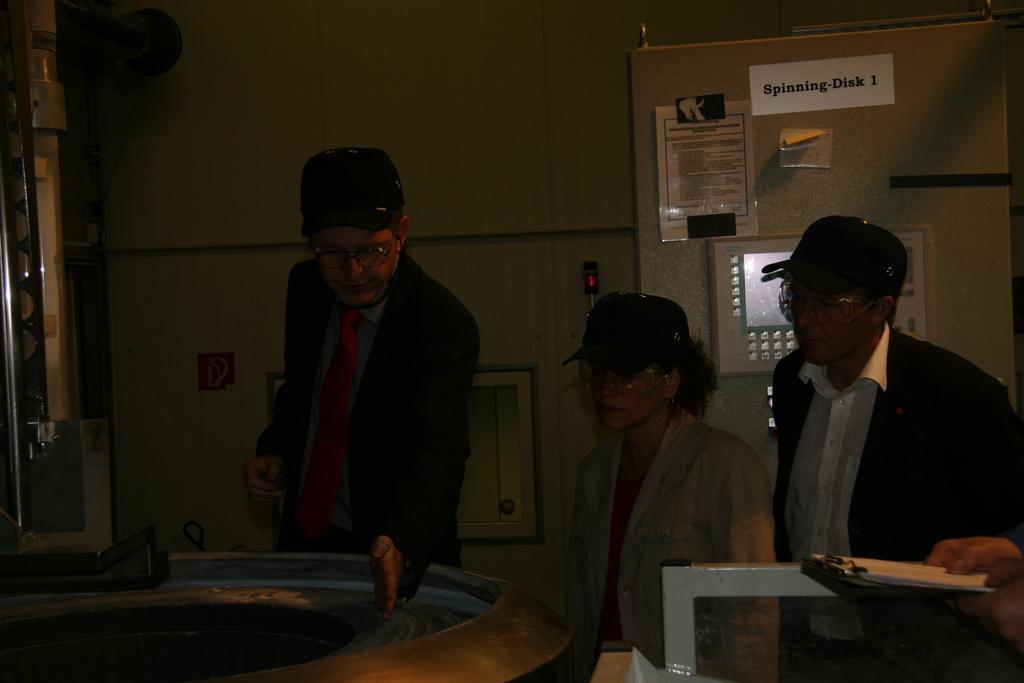In one or two sentences, can you explain what this image depicts? In the foreground, I can see four persons are standing on the floor in front of an object. In the background, I can see a wall, screen, boards and metal objects. This image is taken, maybe in a hall. 